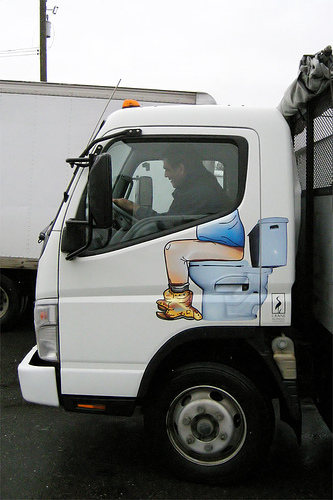<image>
Is the man behind the door? Yes. From this viewpoint, the man is positioned behind the door, with the door partially or fully occluding the man. 